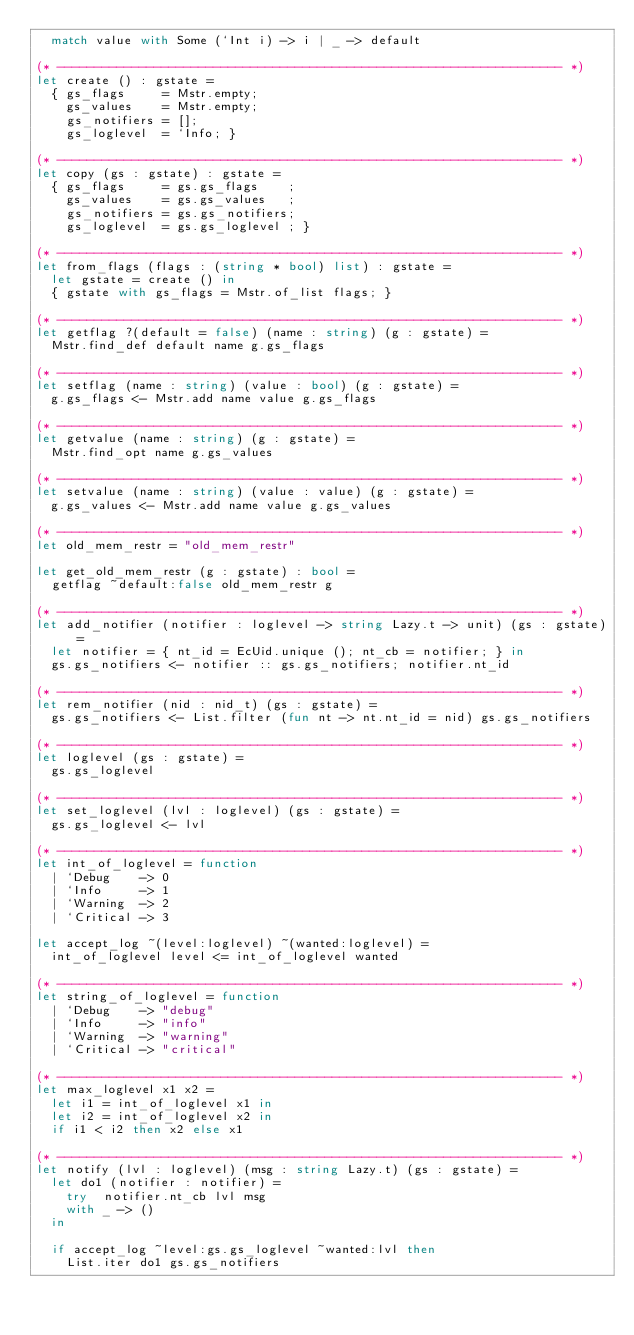Convert code to text. <code><loc_0><loc_0><loc_500><loc_500><_OCaml_>  match value with Some (`Int i) -> i | _ -> default

(* -------------------------------------------------------------------- *)
let create () : gstate =
  { gs_flags     = Mstr.empty;
    gs_values    = Mstr.empty;
    gs_notifiers = [];
    gs_loglevel  = `Info; }

(* -------------------------------------------------------------------- *)
let copy (gs : gstate) : gstate =
  { gs_flags     = gs.gs_flags    ;
    gs_values    = gs.gs_values   ;
    gs_notifiers = gs.gs_notifiers;
    gs_loglevel  = gs.gs_loglevel ; }

(* -------------------------------------------------------------------- *)
let from_flags (flags : (string * bool) list) : gstate =
  let gstate = create () in
  { gstate with gs_flags = Mstr.of_list flags; }

(* -------------------------------------------------------------------- *)
let getflag ?(default = false) (name : string) (g : gstate) =
  Mstr.find_def default name g.gs_flags

(* -------------------------------------------------------------------- *)
let setflag (name : string) (value : bool) (g : gstate) =
  g.gs_flags <- Mstr.add name value g.gs_flags

(* -------------------------------------------------------------------- *)
let getvalue (name : string) (g : gstate) =
  Mstr.find_opt name g.gs_values

(* -------------------------------------------------------------------- *)
let setvalue (name : string) (value : value) (g : gstate) =
  g.gs_values <- Mstr.add name value g.gs_values

(* -------------------------------------------------------------------- *)
let old_mem_restr = "old_mem_restr"

let get_old_mem_restr (g : gstate) : bool =
  getflag ~default:false old_mem_restr g

(* -------------------------------------------------------------------- *)
let add_notifier (notifier : loglevel -> string Lazy.t -> unit) (gs : gstate) =
  let notifier = { nt_id = EcUid.unique (); nt_cb = notifier; } in
  gs.gs_notifiers <- notifier :: gs.gs_notifiers; notifier.nt_id

(* -------------------------------------------------------------------- *)
let rem_notifier (nid : nid_t) (gs : gstate) =
  gs.gs_notifiers <- List.filter (fun nt -> nt.nt_id = nid) gs.gs_notifiers

(* -------------------------------------------------------------------- *)
let loglevel (gs : gstate) =
  gs.gs_loglevel

(* -------------------------------------------------------------------- *)
let set_loglevel (lvl : loglevel) (gs : gstate) =
  gs.gs_loglevel <- lvl

(* -------------------------------------------------------------------- *)
let int_of_loglevel = function
  | `Debug    -> 0
  | `Info     -> 1
  | `Warning  -> 2
  | `Critical -> 3

let accept_log ~(level:loglevel) ~(wanted:loglevel) =
  int_of_loglevel level <= int_of_loglevel wanted

(* -------------------------------------------------------------------- *)
let string_of_loglevel = function
  | `Debug    -> "debug"
  | `Info     -> "info"
  | `Warning  -> "warning"
  | `Critical -> "critical"

(* -------------------------------------------------------------------- *)
let max_loglevel x1 x2 =
  let i1 = int_of_loglevel x1 in
  let i2 = int_of_loglevel x2 in
  if i1 < i2 then x2 else x1

(* -------------------------------------------------------------------- *)
let notify (lvl : loglevel) (msg : string Lazy.t) (gs : gstate) =
  let do1 (notifier : notifier) =
    try  notifier.nt_cb lvl msg
    with _ -> ()
  in

  if accept_log ~level:gs.gs_loglevel ~wanted:lvl then
    List.iter do1 gs.gs_notifiers
</code> 